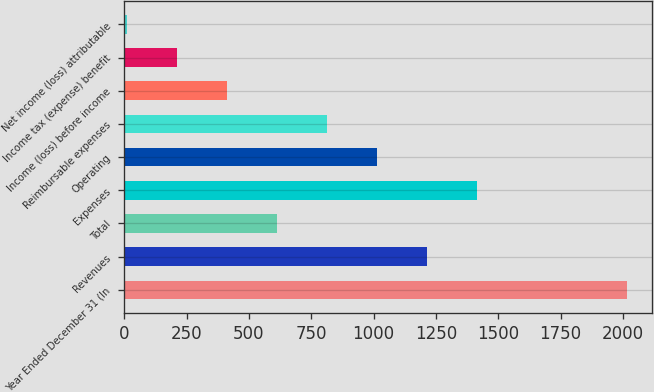Convert chart. <chart><loc_0><loc_0><loc_500><loc_500><bar_chart><fcel>Year Ended December 31 (In<fcel>Revenues<fcel>Total<fcel>Expenses<fcel>Operating<fcel>Reimbursable expenses<fcel>Income (loss) before income<fcel>Income tax (expense) benefit<fcel>Net income (loss) attributable<nl><fcel>2015<fcel>1213.8<fcel>612.9<fcel>1414.1<fcel>1013.5<fcel>813.2<fcel>412.6<fcel>212.3<fcel>12<nl></chart> 